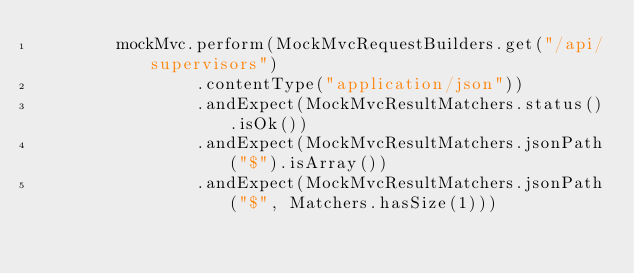Convert code to text. <code><loc_0><loc_0><loc_500><loc_500><_Java_>        mockMvc.perform(MockMvcRequestBuilders.get("/api/supervisors")
                .contentType("application/json"))
                .andExpect(MockMvcResultMatchers.status().isOk())
                .andExpect(MockMvcResultMatchers.jsonPath("$").isArray())
                .andExpect(MockMvcResultMatchers.jsonPath("$", Matchers.hasSize(1)))</code> 